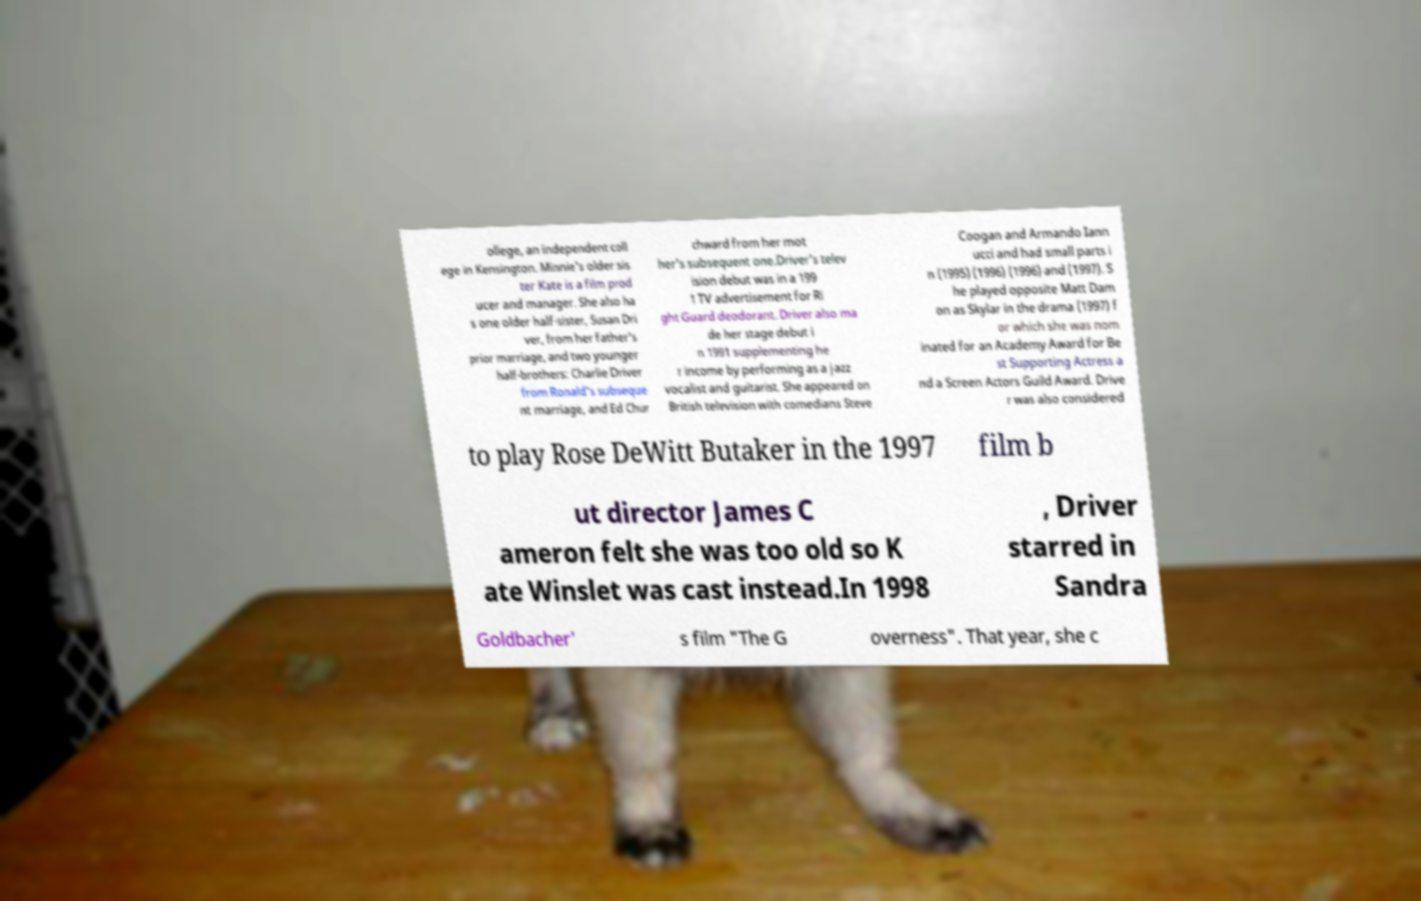Can you accurately transcribe the text from the provided image for me? ollege, an independent coll ege in Kensington. Minnie's older sis ter Kate is a film prod ucer and manager. She also ha s one older half-sister, Susan Dri ver, from her father's prior marriage, and two younger half-brothers: Charlie Driver from Ronald's subseque nt marriage, and Ed Chur chward from her mot her's subsequent one.Driver's telev ision debut was in a 199 1 TV advertisement for Ri ght Guard deodorant. Driver also ma de her stage debut i n 1991 supplementing he r income by performing as a jazz vocalist and guitarist. She appeared on British television with comedians Steve Coogan and Armando Iann ucci and had small parts i n (1995) (1996) (1996) and (1997). S he played opposite Matt Dam on as Skylar in the drama (1997) f or which she was nom inated for an Academy Award for Be st Supporting Actress a nd a Screen Actors Guild Award. Drive r was also considered to play Rose DeWitt Butaker in the 1997 film b ut director James C ameron felt she was too old so K ate Winslet was cast instead.In 1998 , Driver starred in Sandra Goldbacher' s film "The G overness". That year, she c 